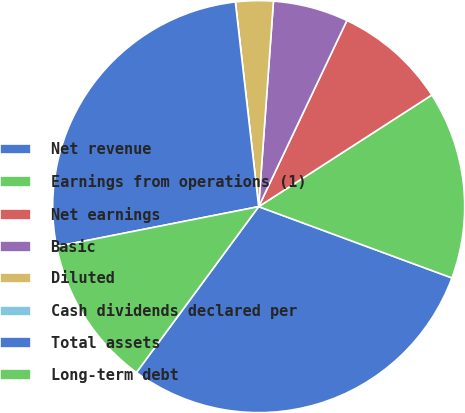Convert chart to OTSL. <chart><loc_0><loc_0><loc_500><loc_500><pie_chart><fcel>Net revenue<fcel>Earnings from operations (1)<fcel>Net earnings<fcel>Basic<fcel>Diluted<fcel>Cash dividends declared per<fcel>Total assets<fcel>Long-term debt<nl><fcel>29.48%<fcel>14.74%<fcel>8.84%<fcel>5.9%<fcel>2.95%<fcel>0.0%<fcel>26.29%<fcel>11.79%<nl></chart> 